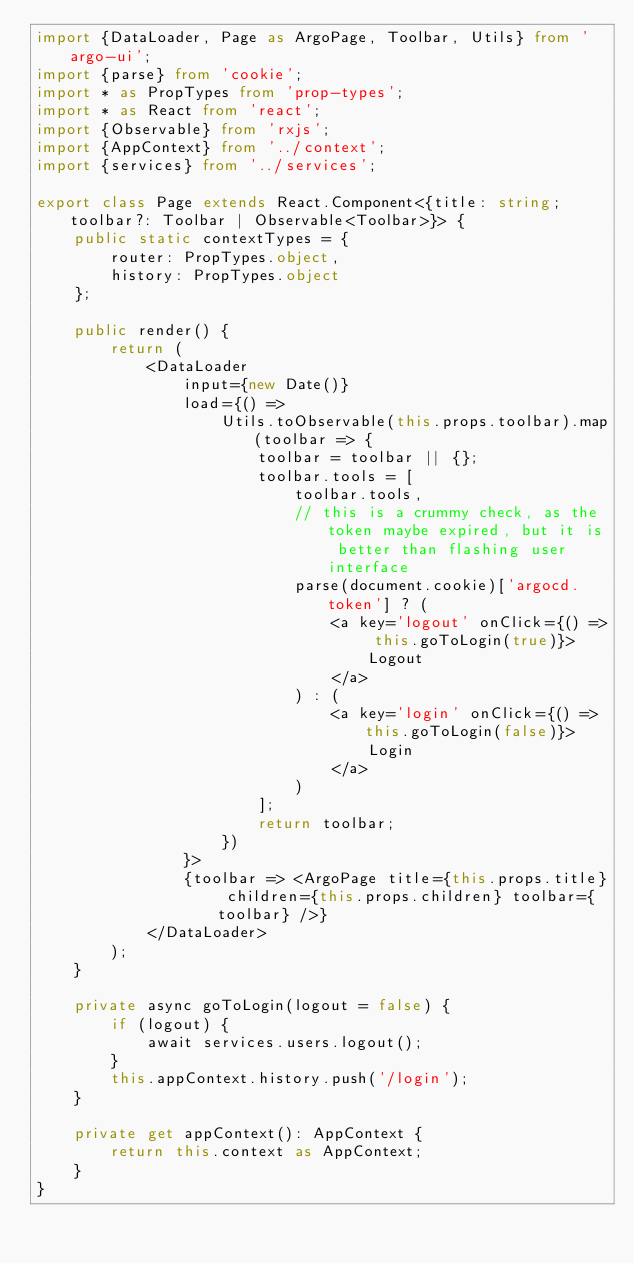<code> <loc_0><loc_0><loc_500><loc_500><_TypeScript_>import {DataLoader, Page as ArgoPage, Toolbar, Utils} from 'argo-ui';
import {parse} from 'cookie';
import * as PropTypes from 'prop-types';
import * as React from 'react';
import {Observable} from 'rxjs';
import {AppContext} from '../context';
import {services} from '../services';

export class Page extends React.Component<{title: string; toolbar?: Toolbar | Observable<Toolbar>}> {
    public static contextTypes = {
        router: PropTypes.object,
        history: PropTypes.object
    };

    public render() {
        return (
            <DataLoader
                input={new Date()}
                load={() =>
                    Utils.toObservable(this.props.toolbar).map(toolbar => {
                        toolbar = toolbar || {};
                        toolbar.tools = [
                            toolbar.tools,
                            // this is a crummy check, as the token maybe expired, but it is better than flashing user interface
                            parse(document.cookie)['argocd.token'] ? (
                                <a key='logout' onClick={() => this.goToLogin(true)}>
                                    Logout
                                </a>
                            ) : (
                                <a key='login' onClick={() => this.goToLogin(false)}>
                                    Login
                                </a>
                            )
                        ];
                        return toolbar;
                    })
                }>
                {toolbar => <ArgoPage title={this.props.title} children={this.props.children} toolbar={toolbar} />}
            </DataLoader>
        );
    }

    private async goToLogin(logout = false) {
        if (logout) {
            await services.users.logout();
        }
        this.appContext.history.push('/login');
    }

    private get appContext(): AppContext {
        return this.context as AppContext;
    }
}
</code> 